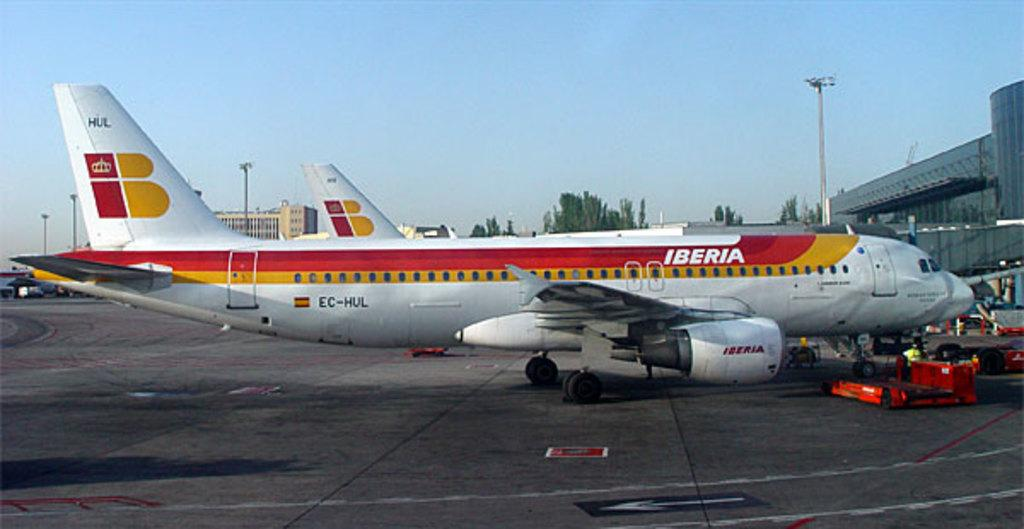Provide a one-sentence caption for the provided image. An Iberia plane with red and orange stripes sitting on a runway. 